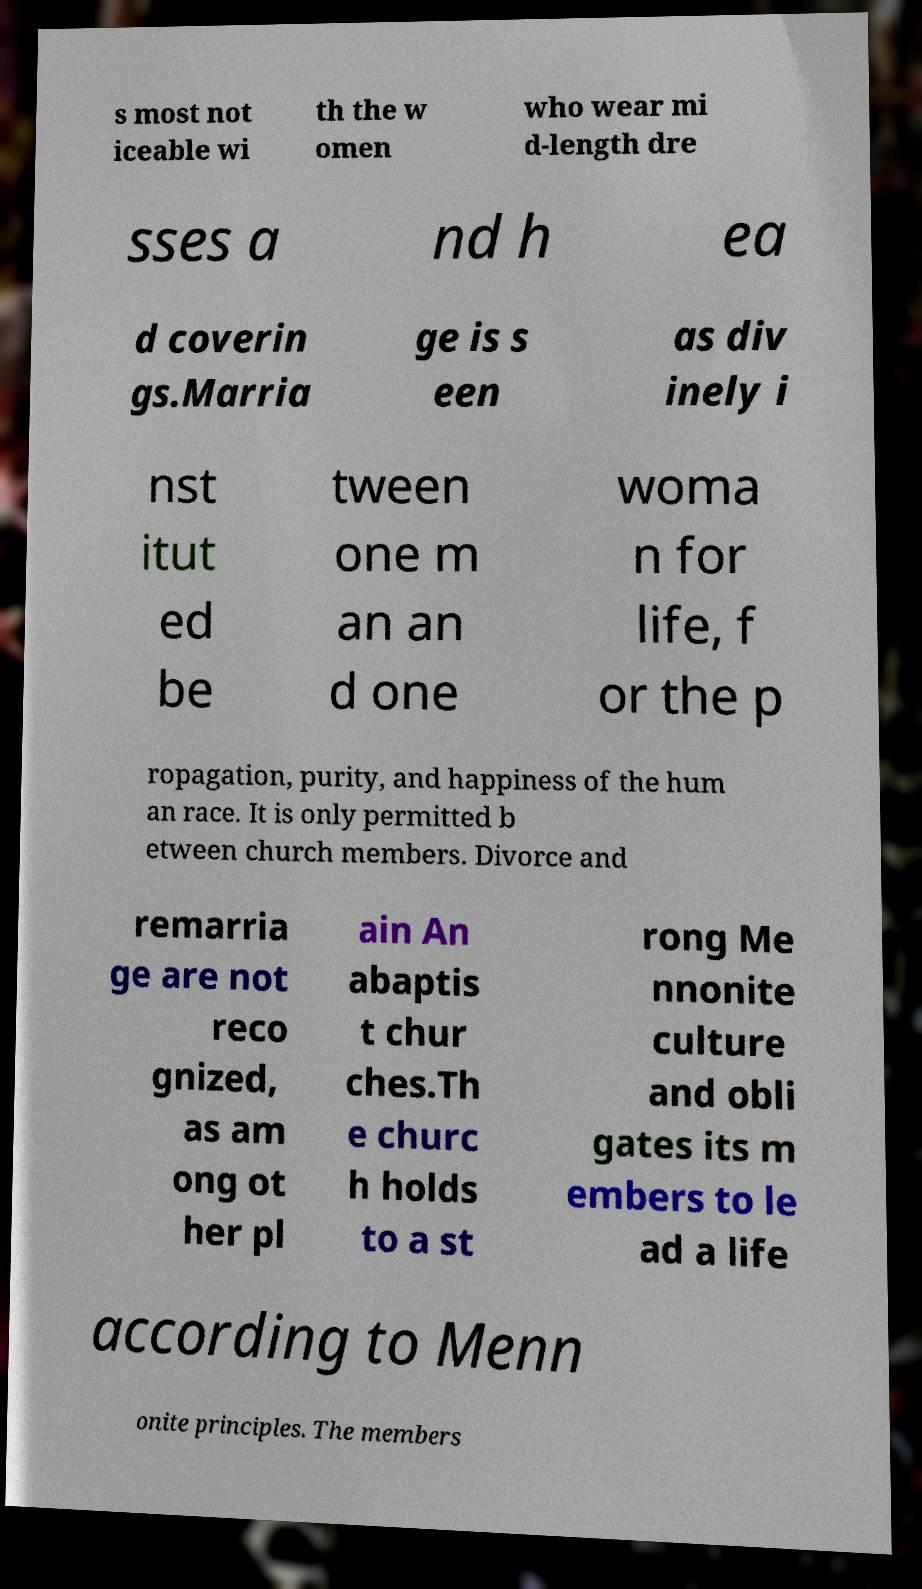What messages or text are displayed in this image? I need them in a readable, typed format. s most not iceable wi th the w omen who wear mi d-length dre sses a nd h ea d coverin gs.Marria ge is s een as div inely i nst itut ed be tween one m an an d one woma n for life, f or the p ropagation, purity, and happiness of the hum an race. It is only permitted b etween church members. Divorce and remarria ge are not reco gnized, as am ong ot her pl ain An abaptis t chur ches.Th e churc h holds to a st rong Me nnonite culture and obli gates its m embers to le ad a life according to Menn onite principles. The members 